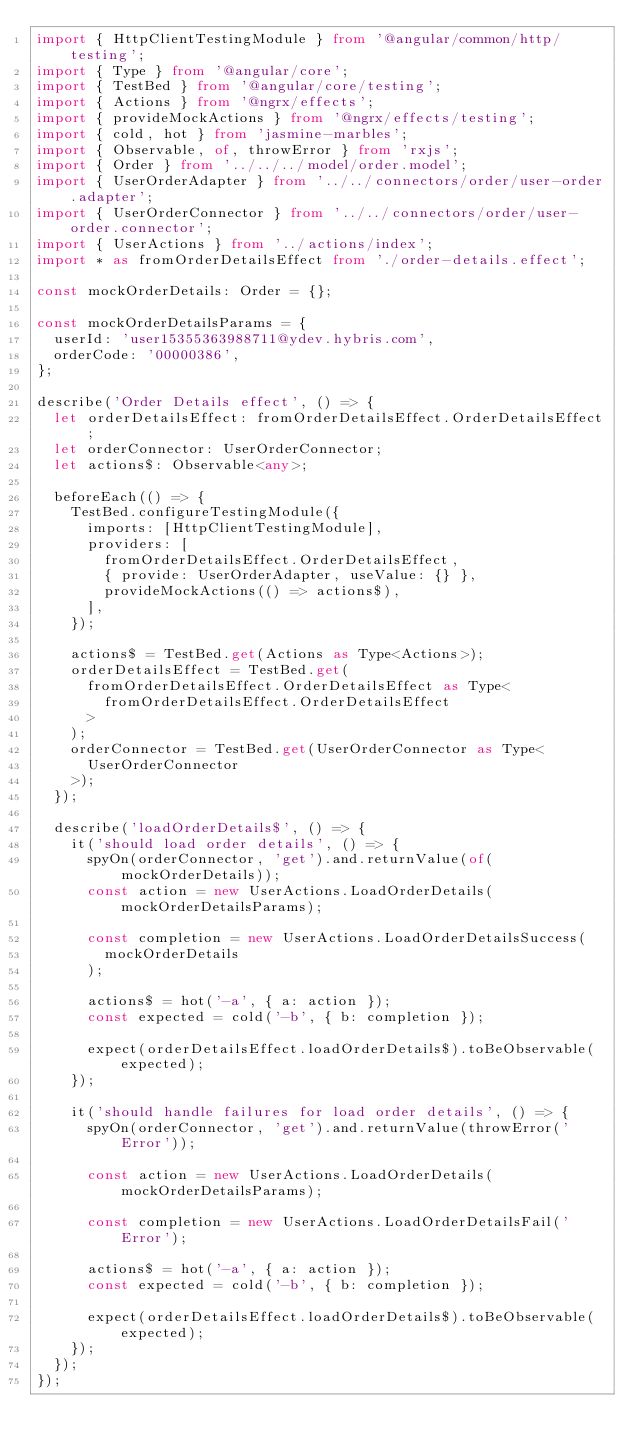Convert code to text. <code><loc_0><loc_0><loc_500><loc_500><_TypeScript_>import { HttpClientTestingModule } from '@angular/common/http/testing';
import { Type } from '@angular/core';
import { TestBed } from '@angular/core/testing';
import { Actions } from '@ngrx/effects';
import { provideMockActions } from '@ngrx/effects/testing';
import { cold, hot } from 'jasmine-marbles';
import { Observable, of, throwError } from 'rxjs';
import { Order } from '../../../model/order.model';
import { UserOrderAdapter } from '../../connectors/order/user-order.adapter';
import { UserOrderConnector } from '../../connectors/order/user-order.connector';
import { UserActions } from '../actions/index';
import * as fromOrderDetailsEffect from './order-details.effect';

const mockOrderDetails: Order = {};

const mockOrderDetailsParams = {
  userId: 'user15355363988711@ydev.hybris.com',
  orderCode: '00000386',
};

describe('Order Details effect', () => {
  let orderDetailsEffect: fromOrderDetailsEffect.OrderDetailsEffect;
  let orderConnector: UserOrderConnector;
  let actions$: Observable<any>;

  beforeEach(() => {
    TestBed.configureTestingModule({
      imports: [HttpClientTestingModule],
      providers: [
        fromOrderDetailsEffect.OrderDetailsEffect,
        { provide: UserOrderAdapter, useValue: {} },
        provideMockActions(() => actions$),
      ],
    });

    actions$ = TestBed.get(Actions as Type<Actions>);
    orderDetailsEffect = TestBed.get(
      fromOrderDetailsEffect.OrderDetailsEffect as Type<
        fromOrderDetailsEffect.OrderDetailsEffect
      >
    );
    orderConnector = TestBed.get(UserOrderConnector as Type<
      UserOrderConnector
    >);
  });

  describe('loadOrderDetails$', () => {
    it('should load order details', () => {
      spyOn(orderConnector, 'get').and.returnValue(of(mockOrderDetails));
      const action = new UserActions.LoadOrderDetails(mockOrderDetailsParams);

      const completion = new UserActions.LoadOrderDetailsSuccess(
        mockOrderDetails
      );

      actions$ = hot('-a', { a: action });
      const expected = cold('-b', { b: completion });

      expect(orderDetailsEffect.loadOrderDetails$).toBeObservable(expected);
    });

    it('should handle failures for load order details', () => {
      spyOn(orderConnector, 'get').and.returnValue(throwError('Error'));

      const action = new UserActions.LoadOrderDetails(mockOrderDetailsParams);

      const completion = new UserActions.LoadOrderDetailsFail('Error');

      actions$ = hot('-a', { a: action });
      const expected = cold('-b', { b: completion });

      expect(orderDetailsEffect.loadOrderDetails$).toBeObservable(expected);
    });
  });
});
</code> 